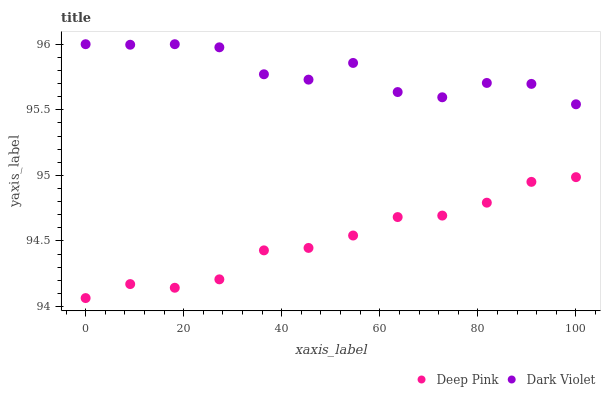Does Deep Pink have the minimum area under the curve?
Answer yes or no. Yes. Does Dark Violet have the maximum area under the curve?
Answer yes or no. Yes. Does Dark Violet have the minimum area under the curve?
Answer yes or no. No. Is Deep Pink the smoothest?
Answer yes or no. Yes. Is Dark Violet the roughest?
Answer yes or no. Yes. Is Dark Violet the smoothest?
Answer yes or no. No. Does Deep Pink have the lowest value?
Answer yes or no. Yes. Does Dark Violet have the lowest value?
Answer yes or no. No. Does Dark Violet have the highest value?
Answer yes or no. Yes. Is Deep Pink less than Dark Violet?
Answer yes or no. Yes. Is Dark Violet greater than Deep Pink?
Answer yes or no. Yes. Does Deep Pink intersect Dark Violet?
Answer yes or no. No. 